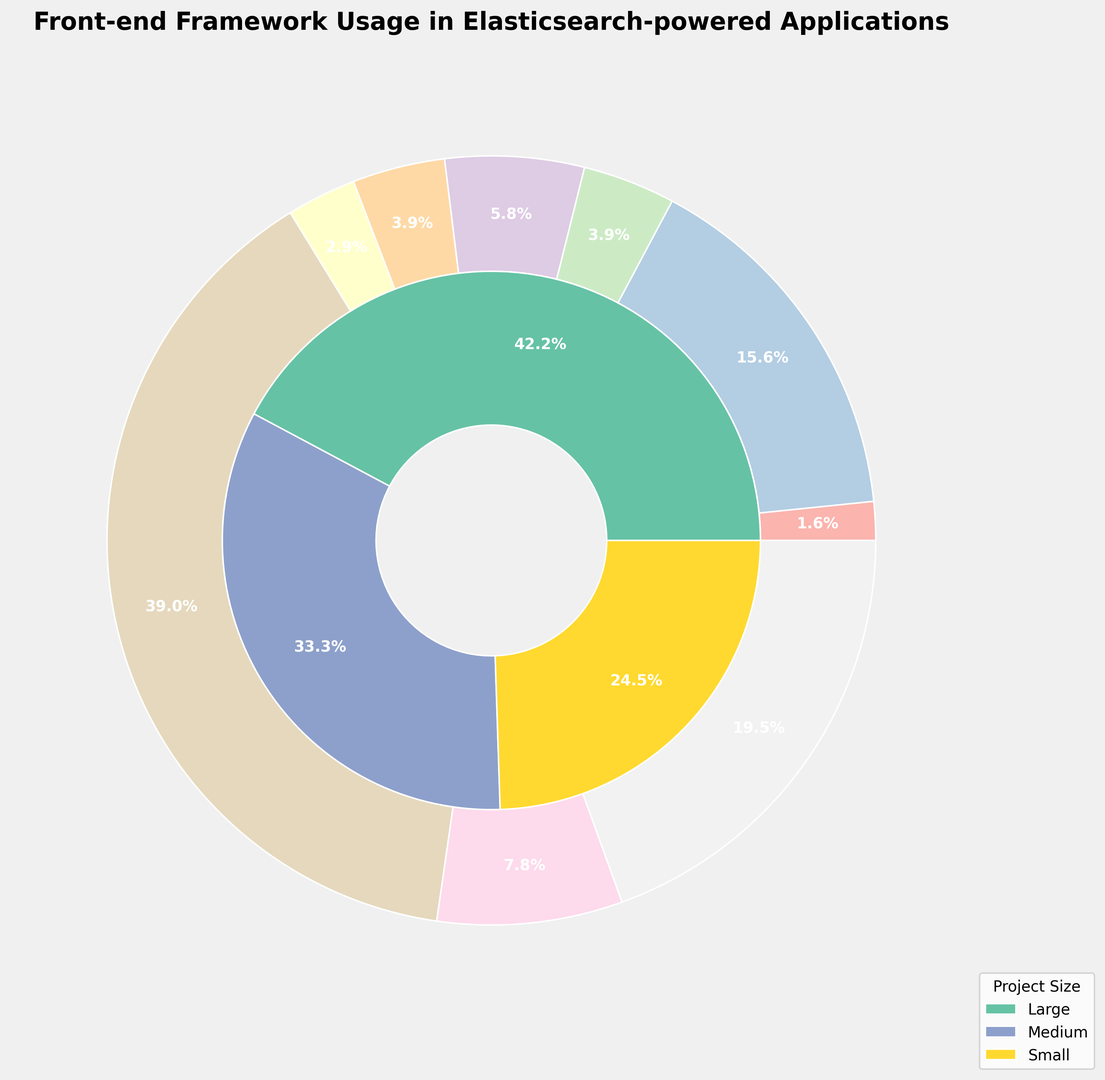What percentage of projects use React? The outer pie chart shows each framework's overall usage percentage. React's segment shows 60%, which is the sum of its small (15%), medium (20%), and large (25%) project contributions.
Answer: 60% Which project size has the highest usage percentage? The inner pie chart illustrates the distribution by project size. The 'Large' project size has the largest segment, indicating the highest usage percentage of 60%.
Answer: Large Is Vue.js usage more common in large or small projects? Compare Vue.js's segments across different project sizes. Vue.js is used in 12% of large projects and 8% of small projects. Therefore, it is more common in large projects.
Answer: Large What is the total percentage of projects using either Alpine.js or Preact? Summing up the respective percentages: Preact's total usage (2% + 1.5% + 1%) = 4.5% and Alpine.js's total usage (1% + 0.8% + 0.7%) = 2.5%. Adding these together gives (4.5% + 2.5%) = 7%.
Answer: 7% Between React and Angular, which framework has higher usage in medium-sized projects? Compare the segments for React and Angular in the medium-sized projects part of the pie chart. React is used in 20% of medium-sized projects, whereas Angular is used in 8%. Thus, React has higher usage.
Answer: React How much higher is the percentage of Vue.js in medium projects compared to Alpine.js in the same category? Vue.js usage in medium projects is 10%, while Alpine.js has 0.8%. The difference is 10% - 0.8% = 9.2%.
Answer: 9.2% What framework has the lowest overall usage and what is it? Identify the smallest segment in the outer pie chart. Alpine.js has the smallest segment, contributing 2.5% to the overall usage (Large 1%, Medium 0.8%, Small 0.7%).
Answer: Alpine.js Which framework in large projects has a usage percentage closest to the average usage in large projects? Sum the percentages of large projects (25 + 12 + 10 + 5 + 3 + 4 + 3 + 2 + 1 = 65%) and calculate the average (65% / 9 frameworks = ~7.22%). Svelte, used in 5% of large projects, is closest to this average.
Answer: Svelte What is the combined usage of Next.js in small and medium projects? Sum the percentages of Next.js usage in small (2%) and medium (3%) projects: (2% + 3%) = 5%.
Answer: 5% 